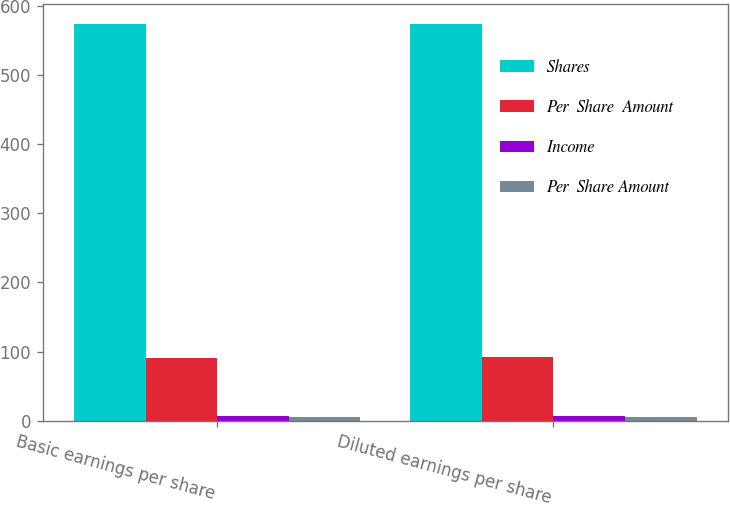Convert chart to OTSL. <chart><loc_0><loc_0><loc_500><loc_500><stacked_bar_chart><ecel><fcel>Basic earnings per share<fcel>Diluted earnings per share<nl><fcel>Shares<fcel>573.8<fcel>573.8<nl><fcel>Per  Share  Amount<fcel>90.2<fcel>91.8<nl><fcel>Income<fcel>6.36<fcel>6.25<nl><fcel>Per  Share Amount<fcel>5.2<fcel>5.11<nl></chart> 